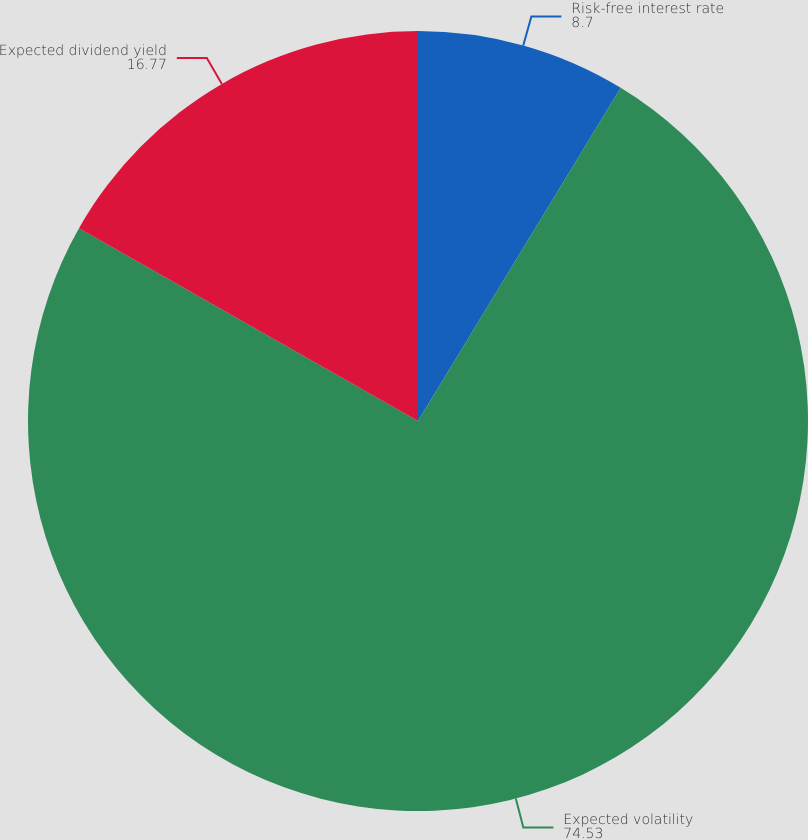<chart> <loc_0><loc_0><loc_500><loc_500><pie_chart><fcel>Risk-free interest rate<fcel>Expected volatility<fcel>Expected dividend yield<nl><fcel>8.7%<fcel>74.53%<fcel>16.77%<nl></chart> 